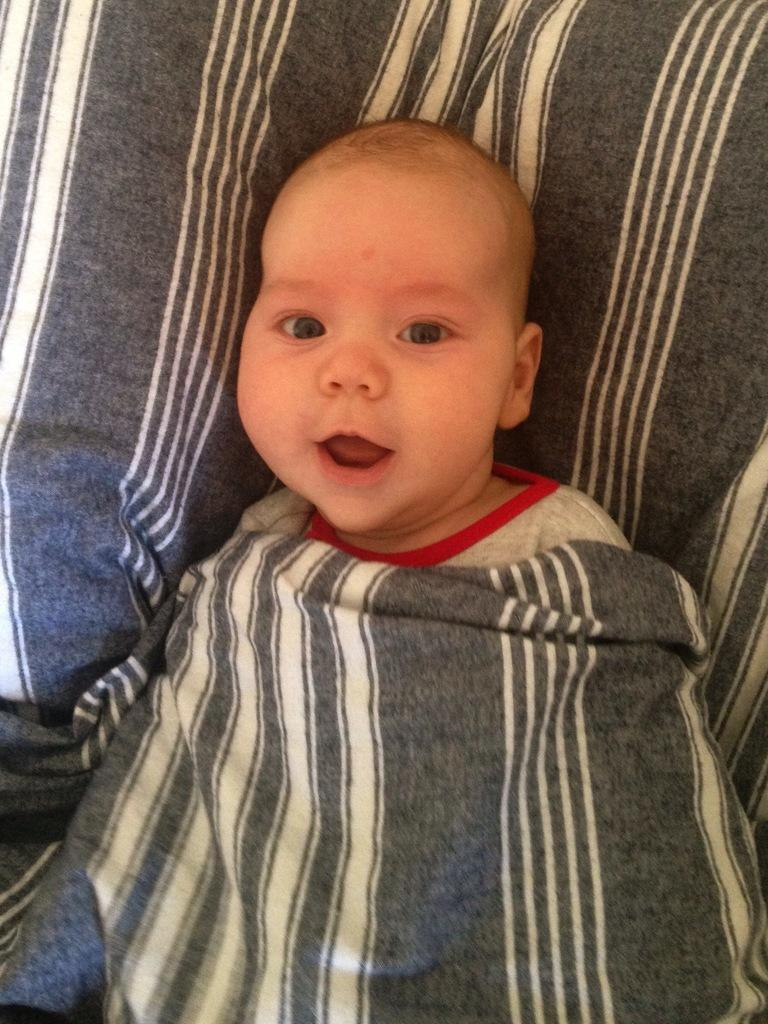Where was the image taken? The image was taken indoors. What is the kid doing in the image? The kid is lying on the bed in the image. What is covering the kid in the image? There is a blanket on the kid in the image. What type of yoke is visible in the image? There is no yoke present in the image. What agreement was reached between the kid and the blanket in the image? There is no agreement between the kid and the blanket in the image; the blanket is simply covering the kid. 